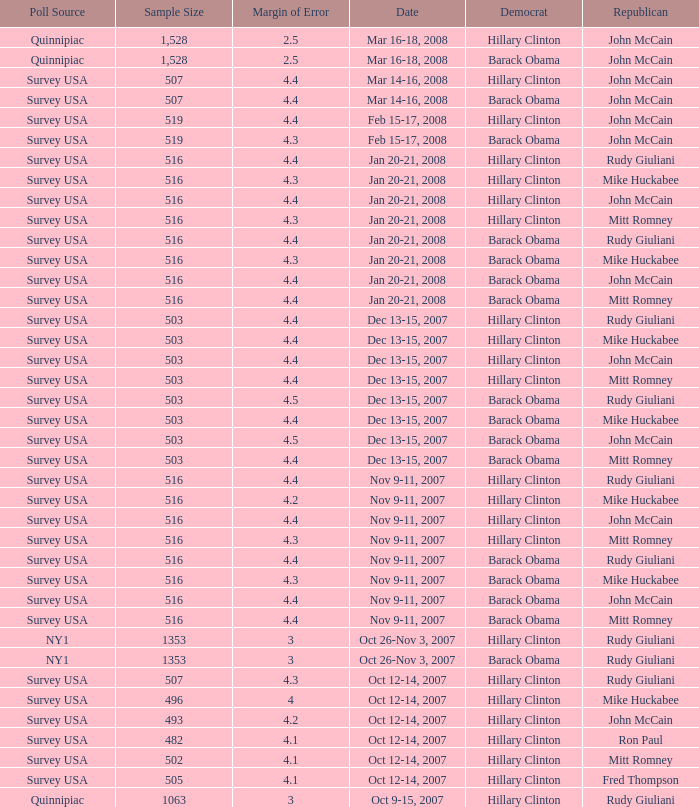What is the sample size of the poll taken on Dec 13-15, 2007 that had a margin of error of more than 4 and resulted with Republican Mike Huckabee? 503.0. 